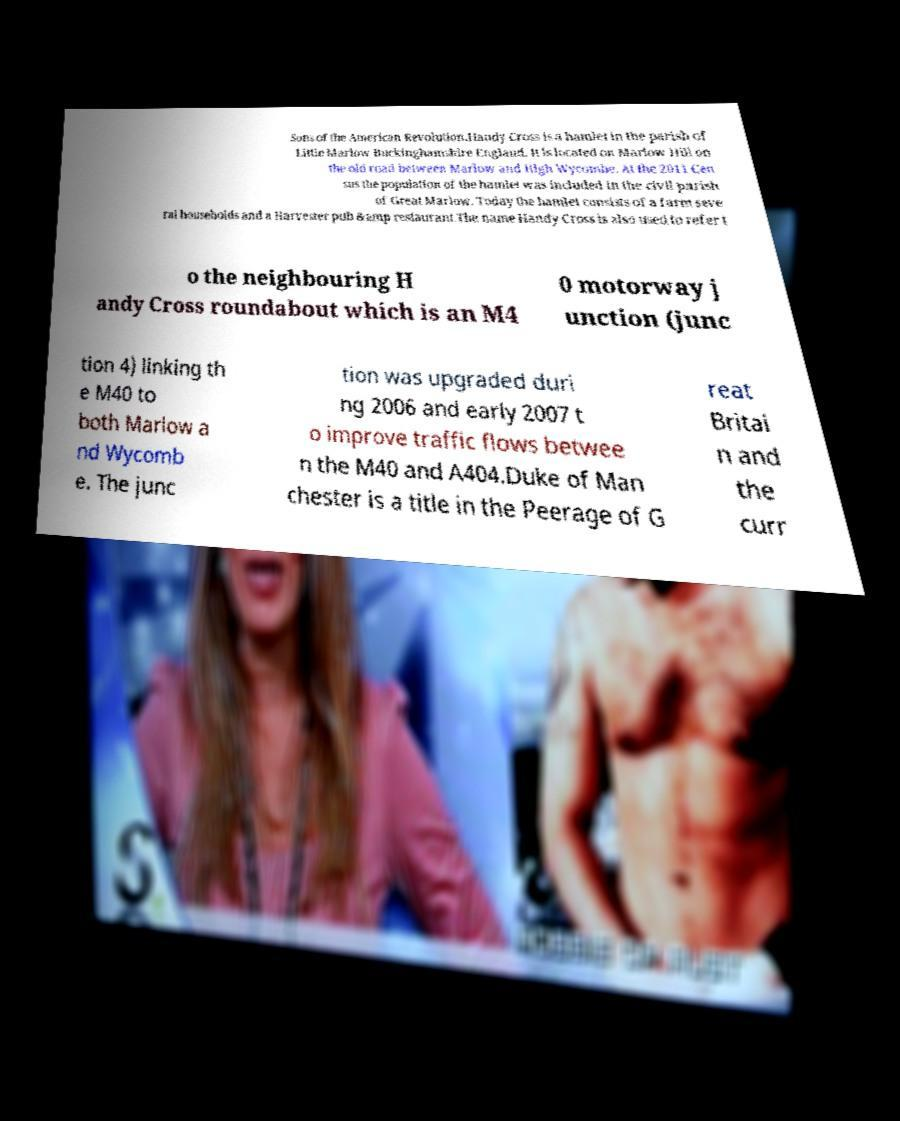Please read and relay the text visible in this image. What does it say? Sons of the American Revolution.Handy Cross is a hamlet in the parish of Little Marlow Buckinghamshire England. It is located on Marlow Hill on the old road between Marlow and High Wycombe. At the 2011 Cen sus the population of the hamlet was included in the civil parish of Great Marlow. Today the hamlet consists of a farm seve ral households and a Harvester pub &amp restaurant.The name Handy Cross is also used to refer t o the neighbouring H andy Cross roundabout which is an M4 0 motorway j unction (junc tion 4) linking th e M40 to both Marlow a nd Wycomb e. The junc tion was upgraded duri ng 2006 and early 2007 t o improve traffic flows betwee n the M40 and A404.Duke of Man chester is a title in the Peerage of G reat Britai n and the curr 